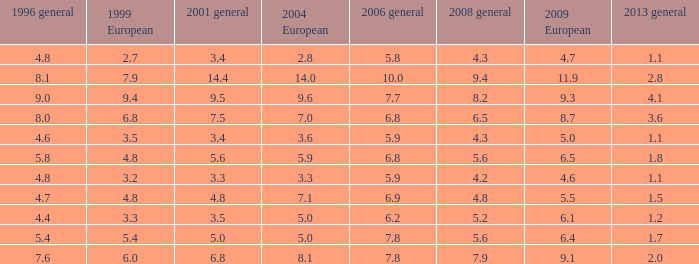What is the average value for general 2001 with more than 4.8 in 1999 European, 7.7 in 2006 general, and more than 9 in 1996 general? None. 